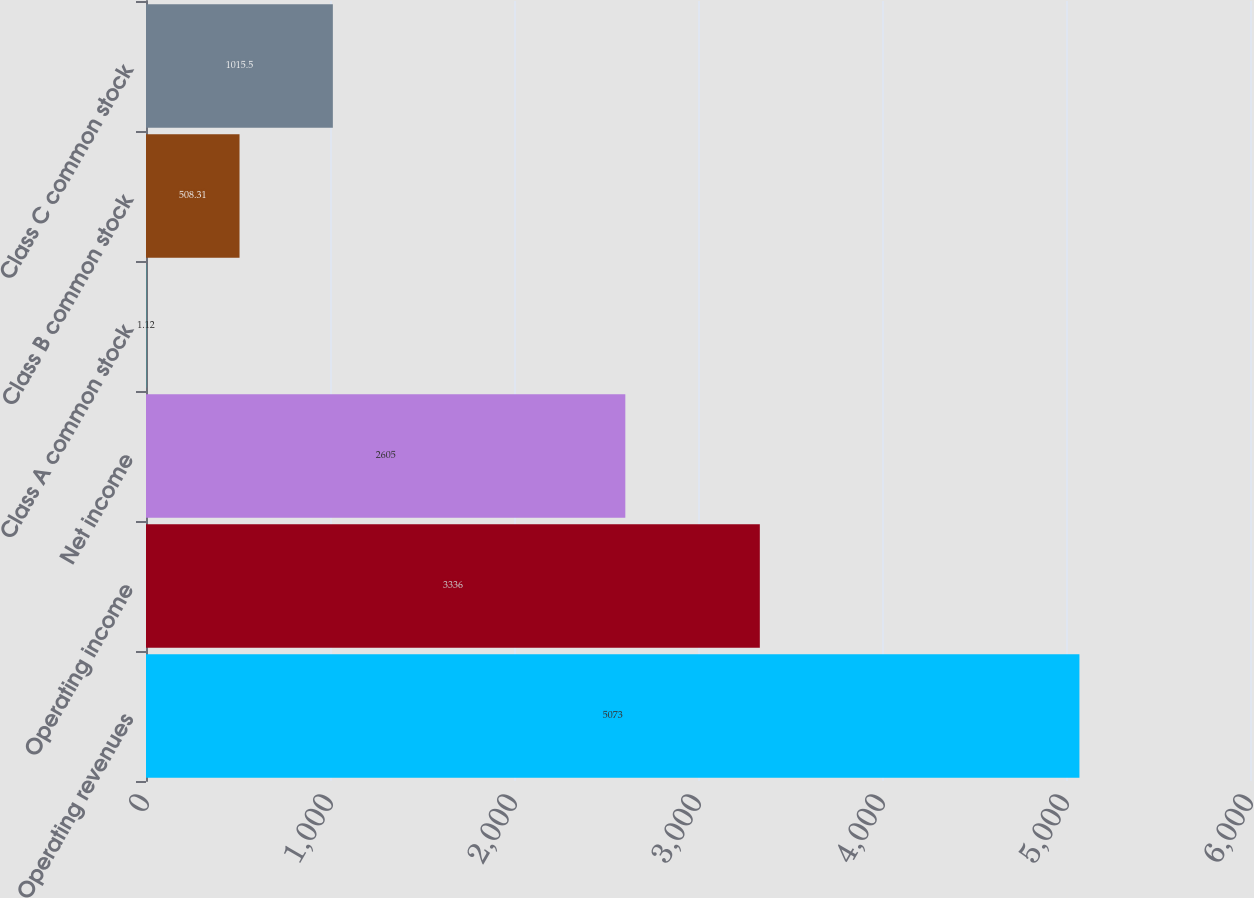<chart> <loc_0><loc_0><loc_500><loc_500><bar_chart><fcel>Operating revenues<fcel>Operating income<fcel>Net income<fcel>Class A common stock<fcel>Class B common stock<fcel>Class C common stock<nl><fcel>5073<fcel>3336<fcel>2605<fcel>1.12<fcel>508.31<fcel>1015.5<nl></chart> 